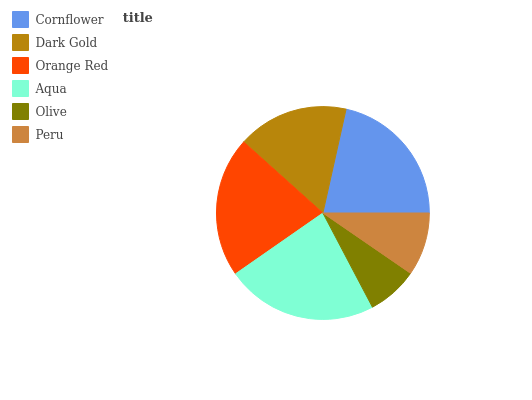Is Olive the minimum?
Answer yes or no. Yes. Is Aqua the maximum?
Answer yes or no. Yes. Is Dark Gold the minimum?
Answer yes or no. No. Is Dark Gold the maximum?
Answer yes or no. No. Is Cornflower greater than Dark Gold?
Answer yes or no. Yes. Is Dark Gold less than Cornflower?
Answer yes or no. Yes. Is Dark Gold greater than Cornflower?
Answer yes or no. No. Is Cornflower less than Dark Gold?
Answer yes or no. No. Is Orange Red the high median?
Answer yes or no. Yes. Is Dark Gold the low median?
Answer yes or no. Yes. Is Aqua the high median?
Answer yes or no. No. Is Cornflower the low median?
Answer yes or no. No. 